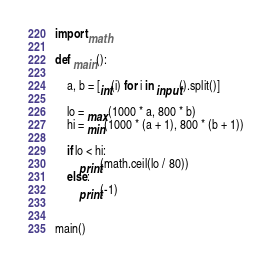Convert code to text. <code><loc_0><loc_0><loc_500><loc_500><_Python_>import math

def main():

    a, b = [int(i) for i in input().split()]

    lo = max(1000 * a, 800 * b)
    hi = min(1000 * (a + 1), 800 * (b + 1))

    if lo < hi:
        print(math.ceil(lo / 80))
    else:
        print(-1)


main()
</code> 